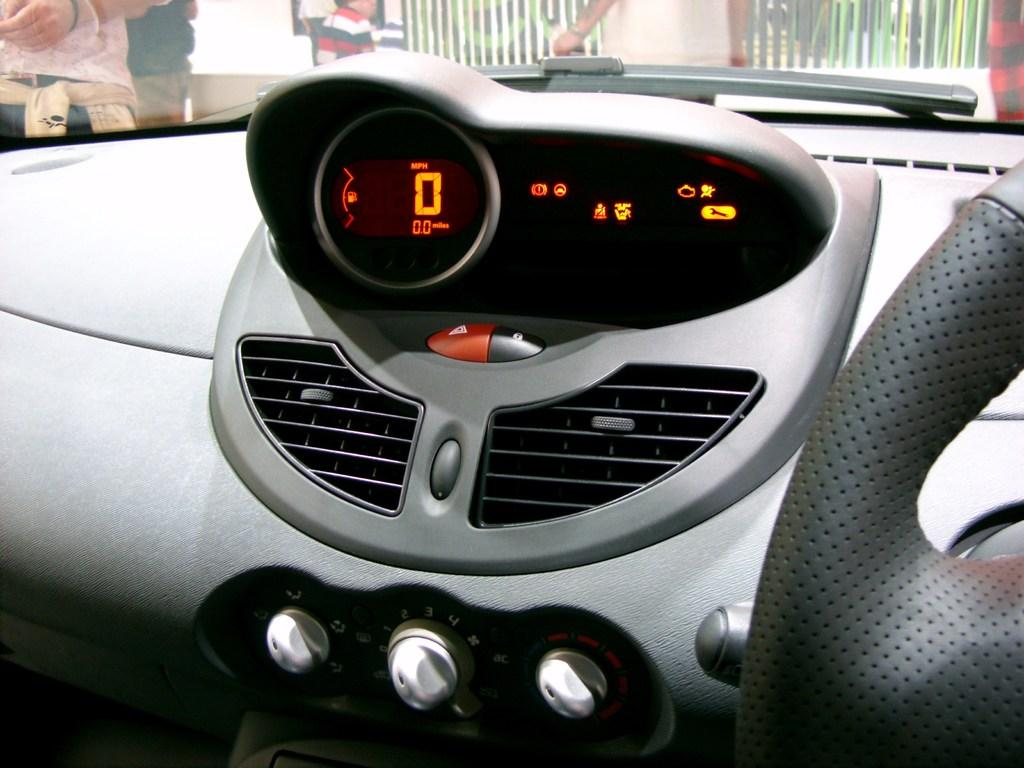What is the main subject of the image? The image shows a car dashboard. What specific feature can be seen on the dashboard? There is an odometer visible on the dashboard. What is another component of the car that is visible in the image? There is a steering wheel in the image. What else can be seen in the image besides the car dashboard? There are people standing in the image, and there is a metal fence. What type of books can be seen in the car's basin? There is no basin or books present in the image; it shows a car dashboard with an odometer, steering wheel, people, and a metal fence. 